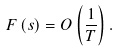Convert formula to latex. <formula><loc_0><loc_0><loc_500><loc_500>F \left ( s \right ) = O \left ( \frac { 1 } { T } \right ) .</formula> 